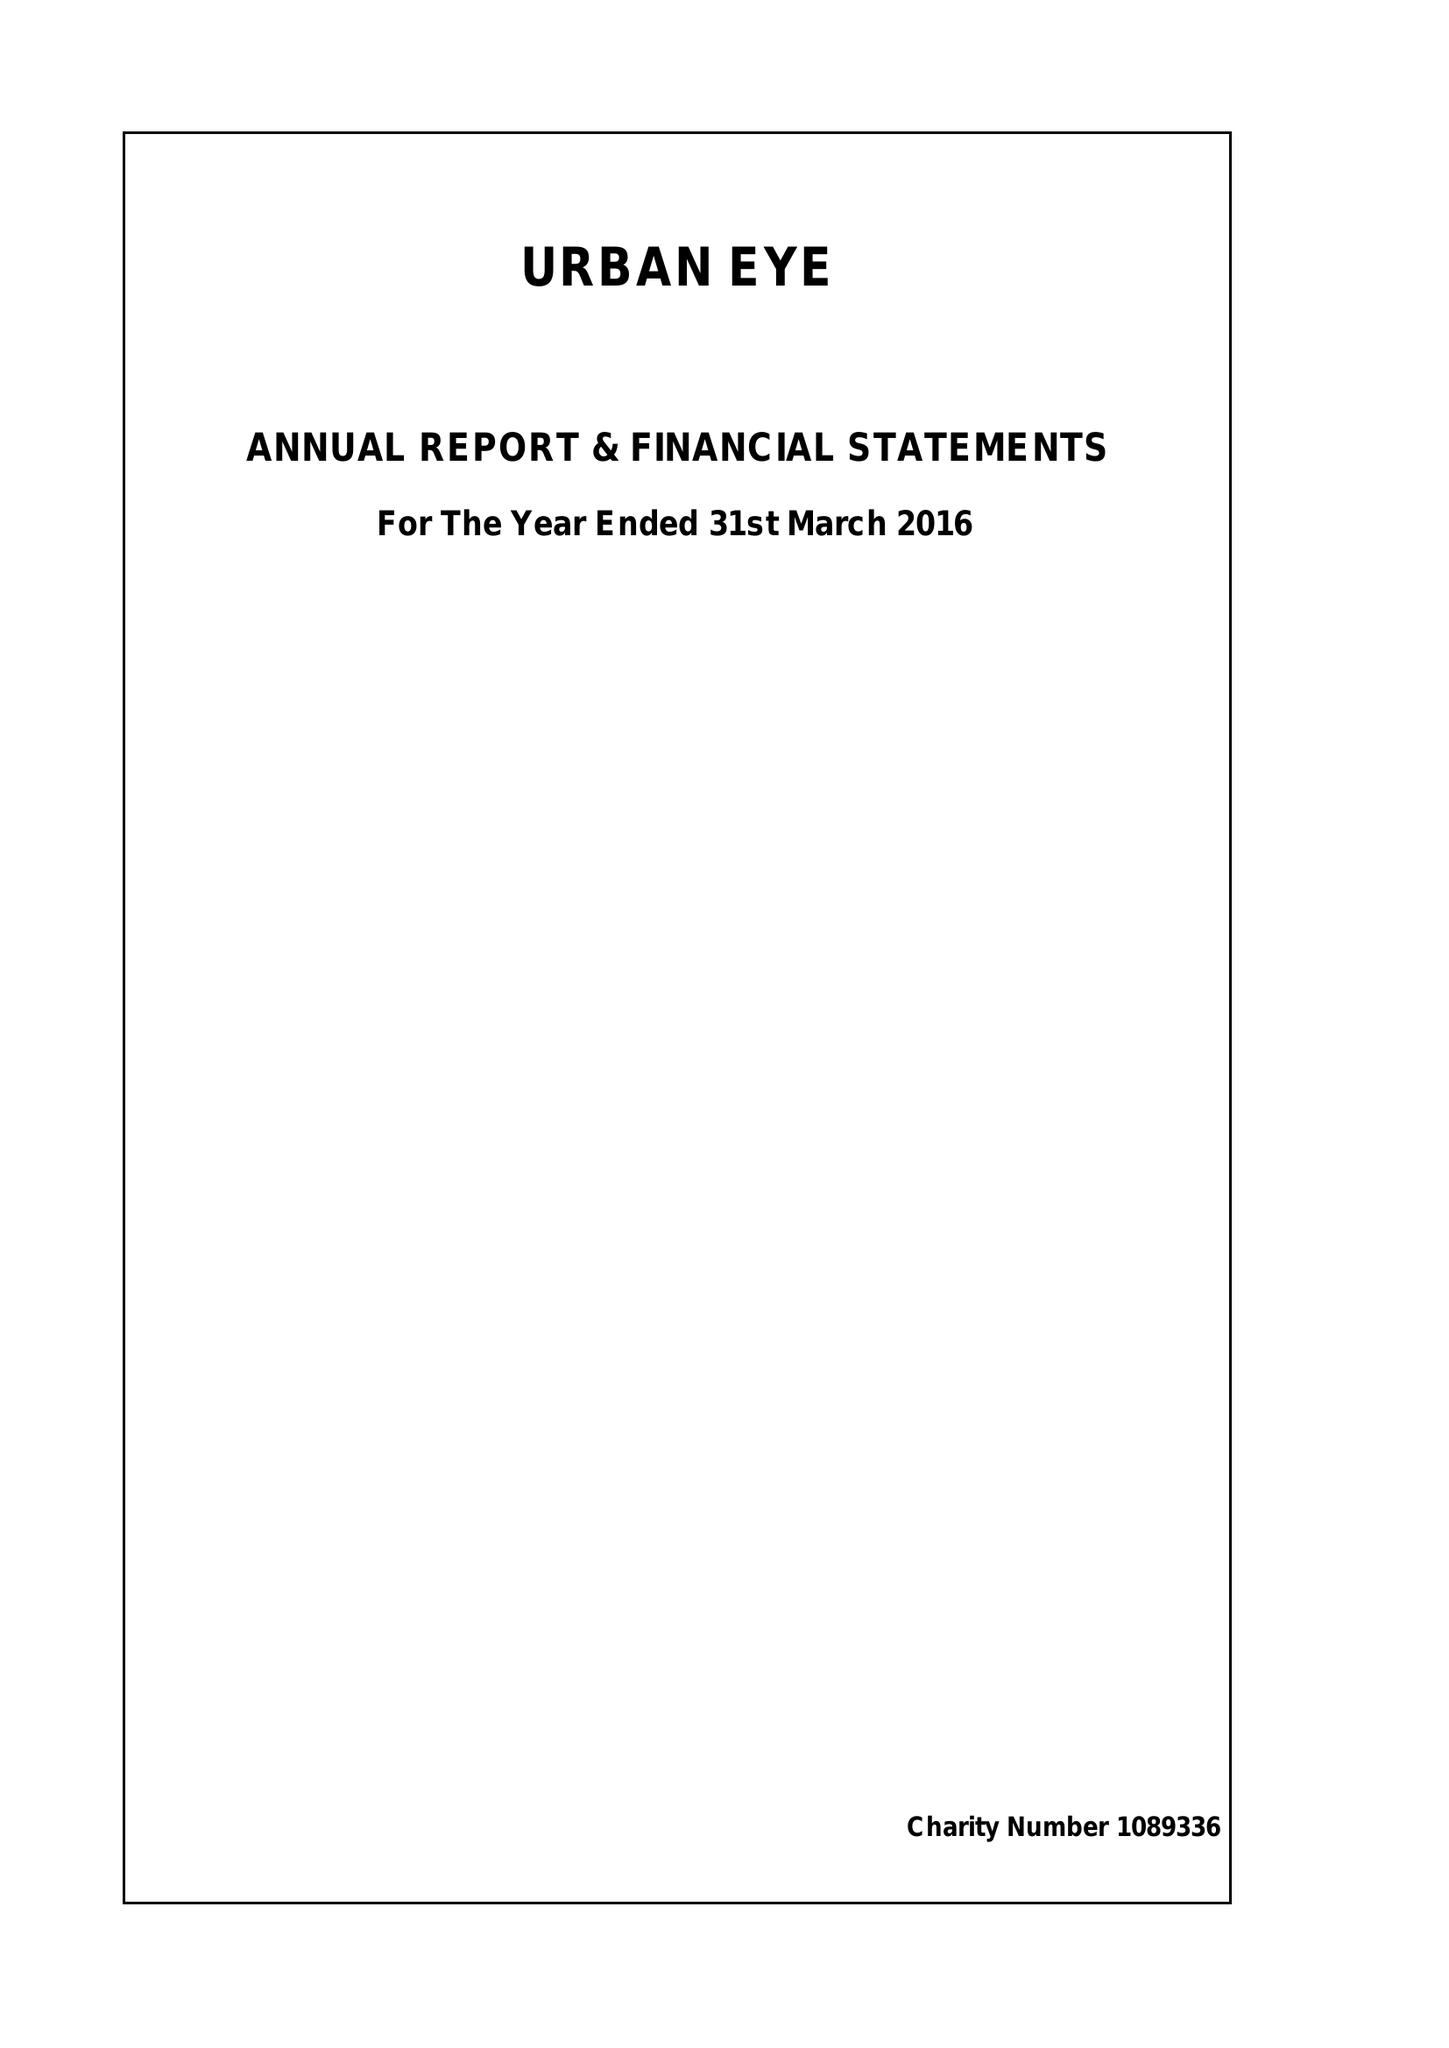What is the value for the charity_name?
Answer the question using a single word or phrase. Urban Eye 